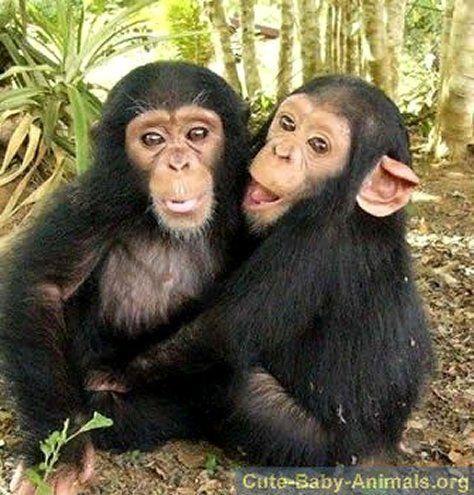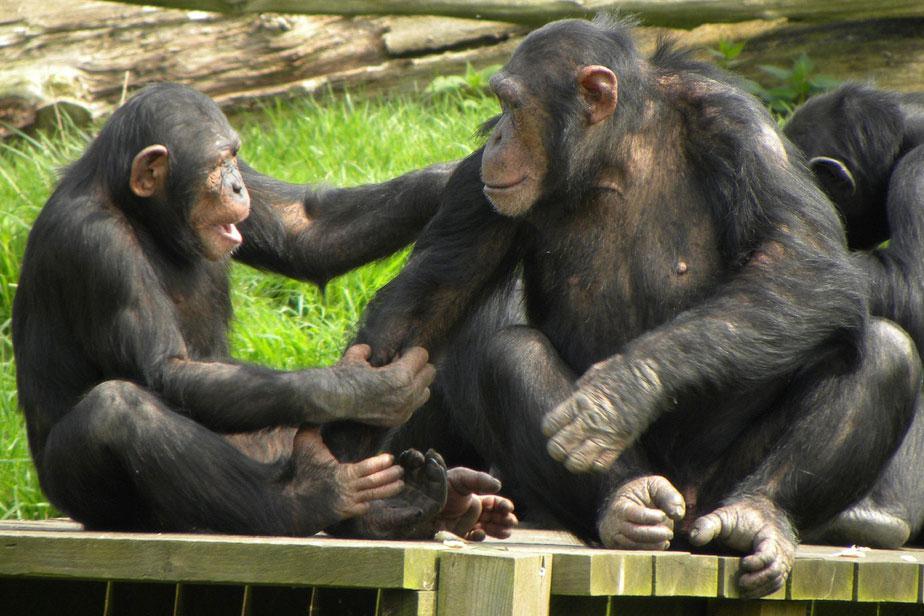The first image is the image on the left, the second image is the image on the right. Considering the images on both sides, is "Each image has two primates in the wild." valid? Answer yes or no. No. The first image is the image on the left, the second image is the image on the right. Assess this claim about the two images: "The chimp on the left has both arms extended to grasp the chimp on the right in an image.". Correct or not? Answer yes or no. Yes. 